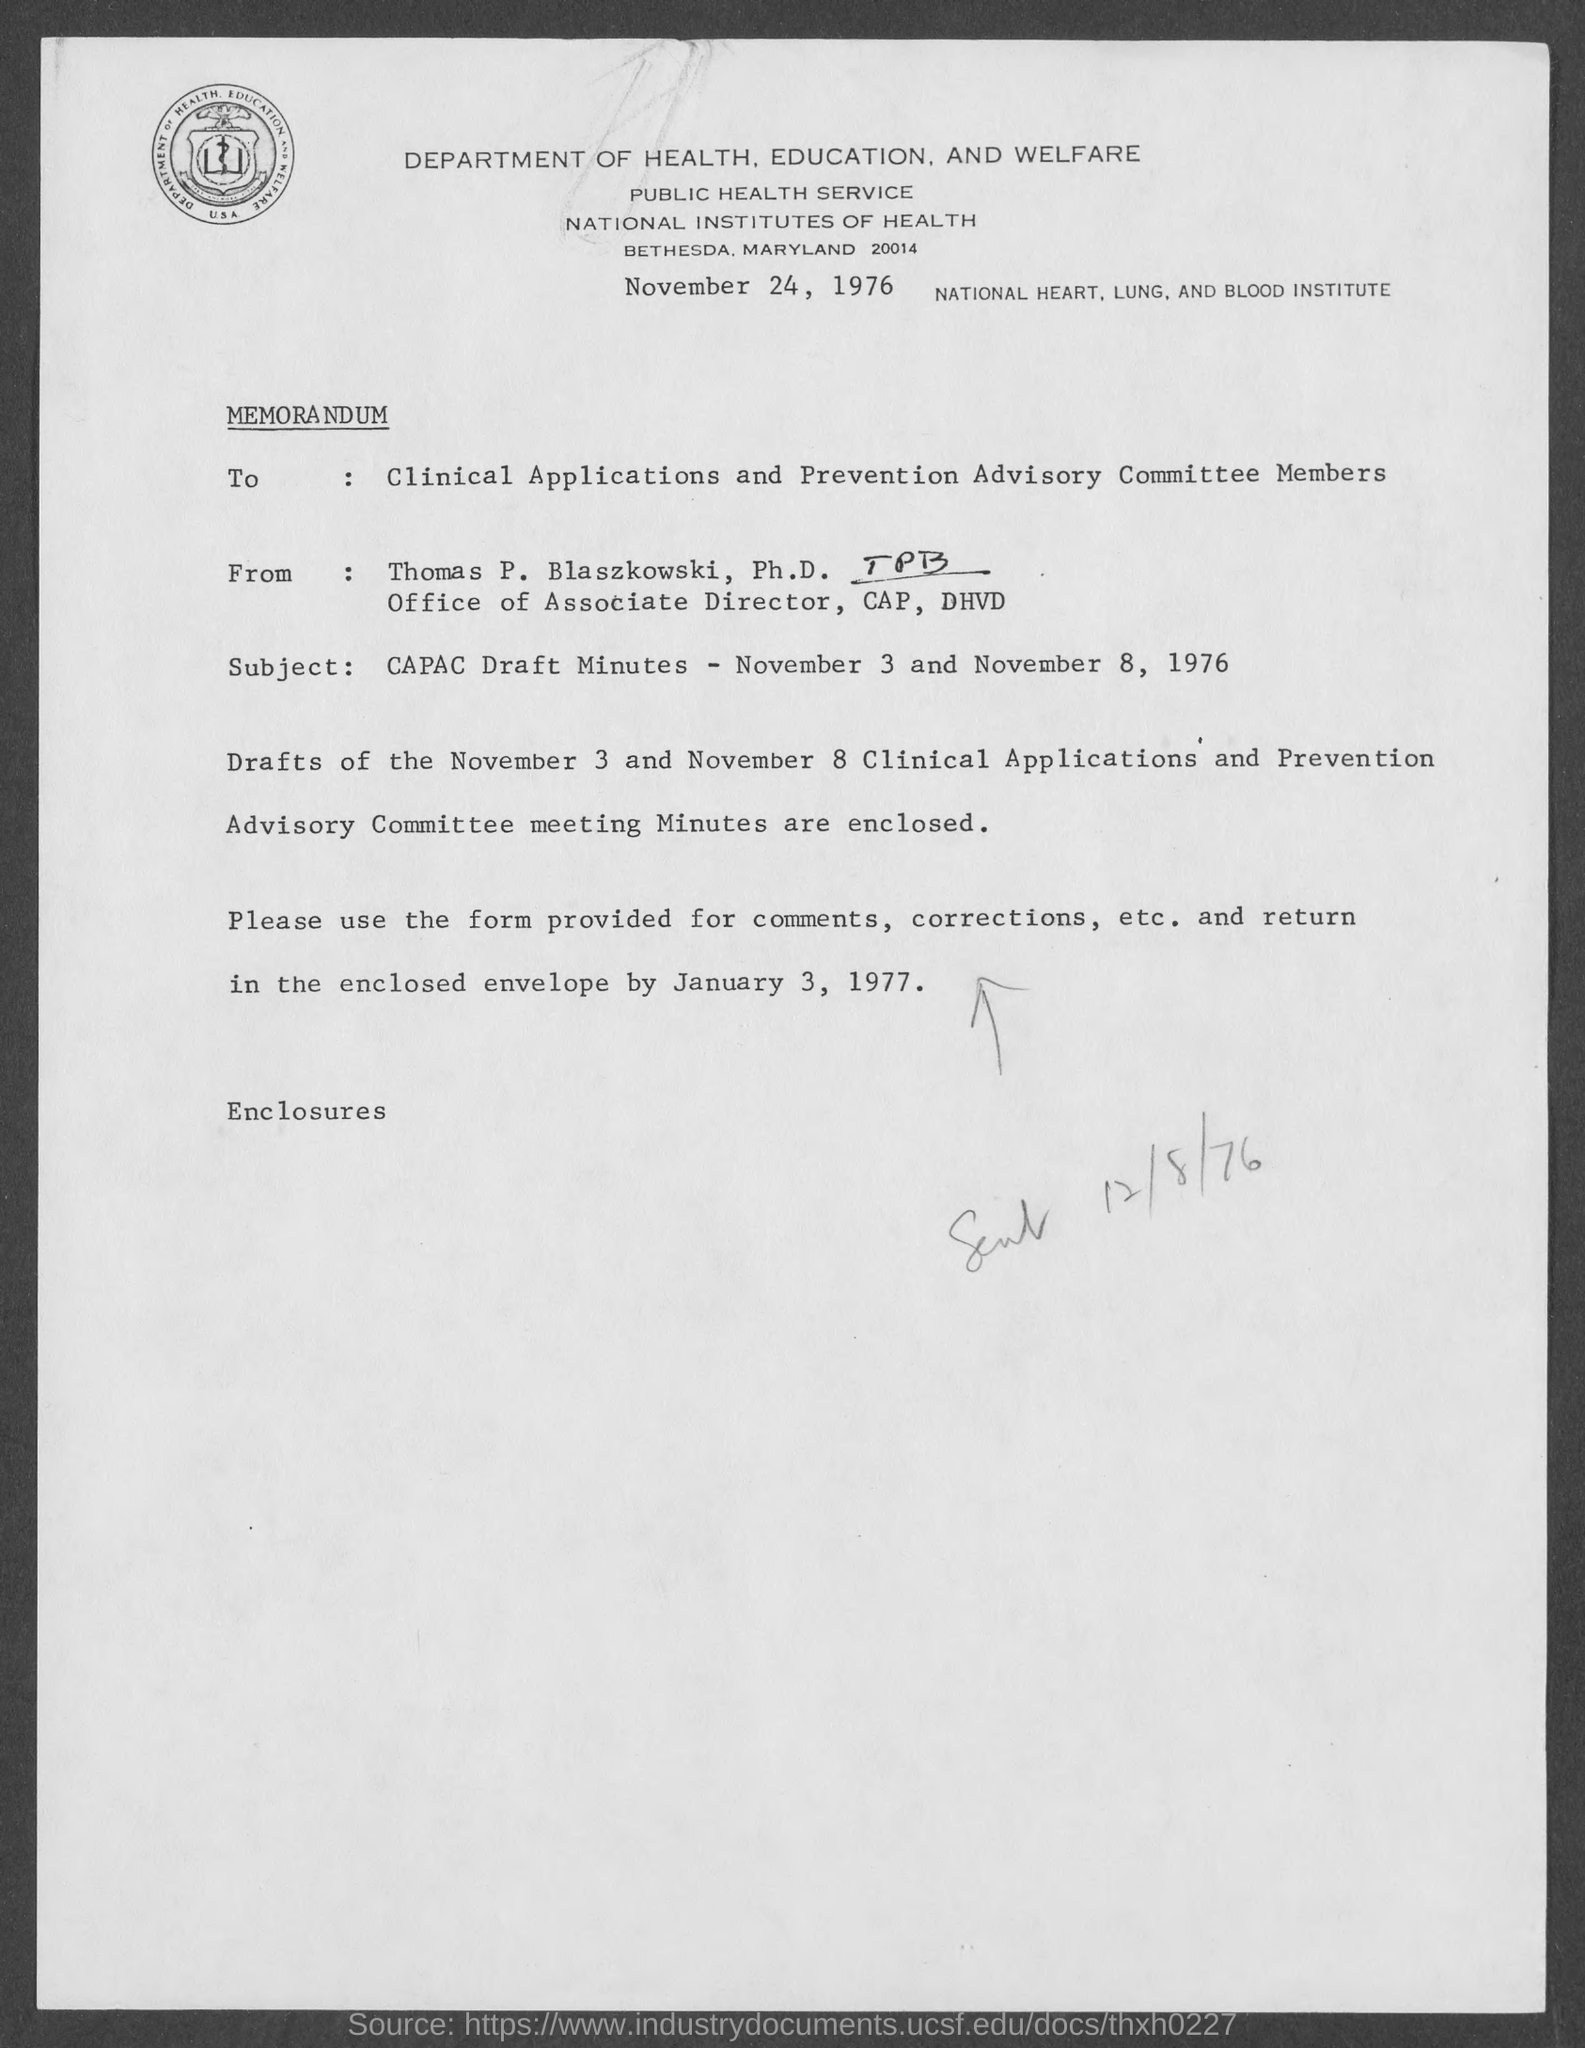Who wrote letter?
Your response must be concise. Thomas P. Blaszkowski, Ph.D. To whom the letter is written?
Provide a short and direct response. Clinical applications and prevention advisory committee members. What is Subject written?
Give a very brief answer. CAPAC Draft Minutes - November 3 and November 8, 1976. 